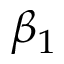Convert formula to latex. <formula><loc_0><loc_0><loc_500><loc_500>\beta _ { 1 }</formula> 